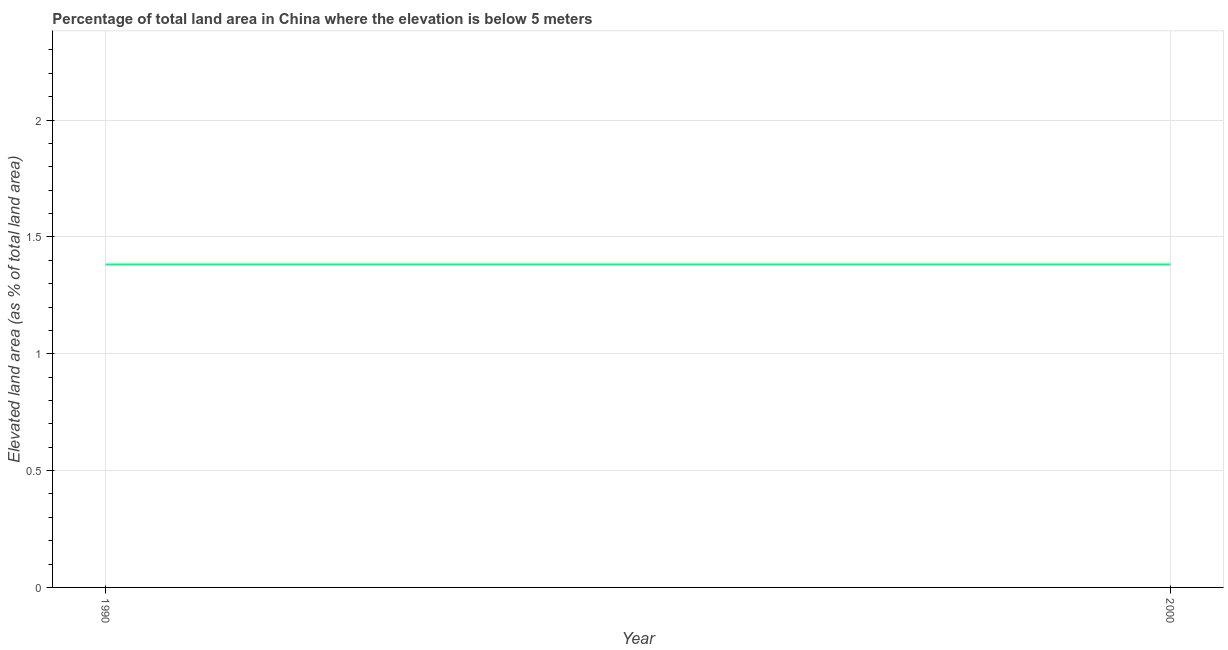What is the total elevated land area in 2000?
Your answer should be compact. 1.38. Across all years, what is the maximum total elevated land area?
Your response must be concise. 1.38. Across all years, what is the minimum total elevated land area?
Ensure brevity in your answer.  1.38. In which year was the total elevated land area minimum?
Make the answer very short. 1990. What is the sum of the total elevated land area?
Offer a terse response. 2.76. What is the average total elevated land area per year?
Provide a succinct answer. 1.38. What is the median total elevated land area?
Your answer should be very brief. 1.38. In how many years, is the total elevated land area greater than 0.4 %?
Your answer should be compact. 2. What is the ratio of the total elevated land area in 1990 to that in 2000?
Make the answer very short. 1. Is the total elevated land area in 1990 less than that in 2000?
Your response must be concise. No. Does the total elevated land area monotonically increase over the years?
Your answer should be very brief. No. How many lines are there?
Your answer should be very brief. 1. How many years are there in the graph?
Offer a terse response. 2. What is the difference between two consecutive major ticks on the Y-axis?
Your response must be concise. 0.5. Does the graph contain any zero values?
Your answer should be very brief. No. What is the title of the graph?
Provide a succinct answer. Percentage of total land area in China where the elevation is below 5 meters. What is the label or title of the Y-axis?
Offer a very short reply. Elevated land area (as % of total land area). What is the Elevated land area (as % of total land area) of 1990?
Give a very brief answer. 1.38. What is the Elevated land area (as % of total land area) of 2000?
Your answer should be very brief. 1.38. What is the difference between the Elevated land area (as % of total land area) in 1990 and 2000?
Keep it short and to the point. 0. What is the ratio of the Elevated land area (as % of total land area) in 1990 to that in 2000?
Offer a terse response. 1. 